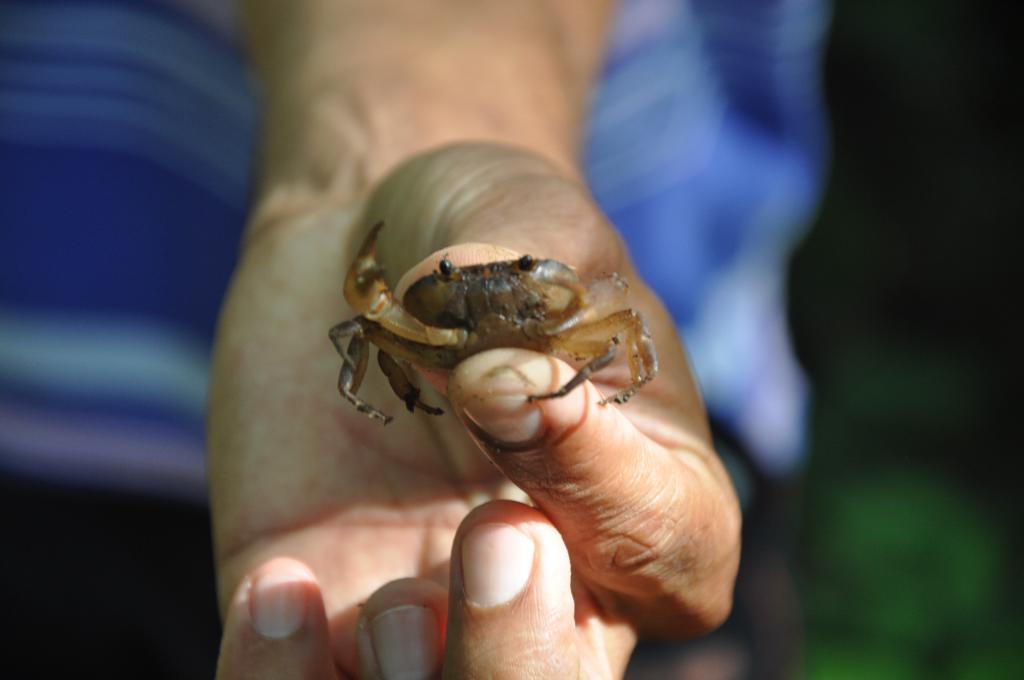What is the hand holding in the image? The hand is holding a crab in the image. What part of the hand can be seen? The fingers of the hand are visible. Can you describe the background of the image? The background of the image is blurry. How does the scarecrow protect the crops from the rainstorm in the image? There is no scarecrow or rainstorm present in the image; it features a hand holding a crab. 